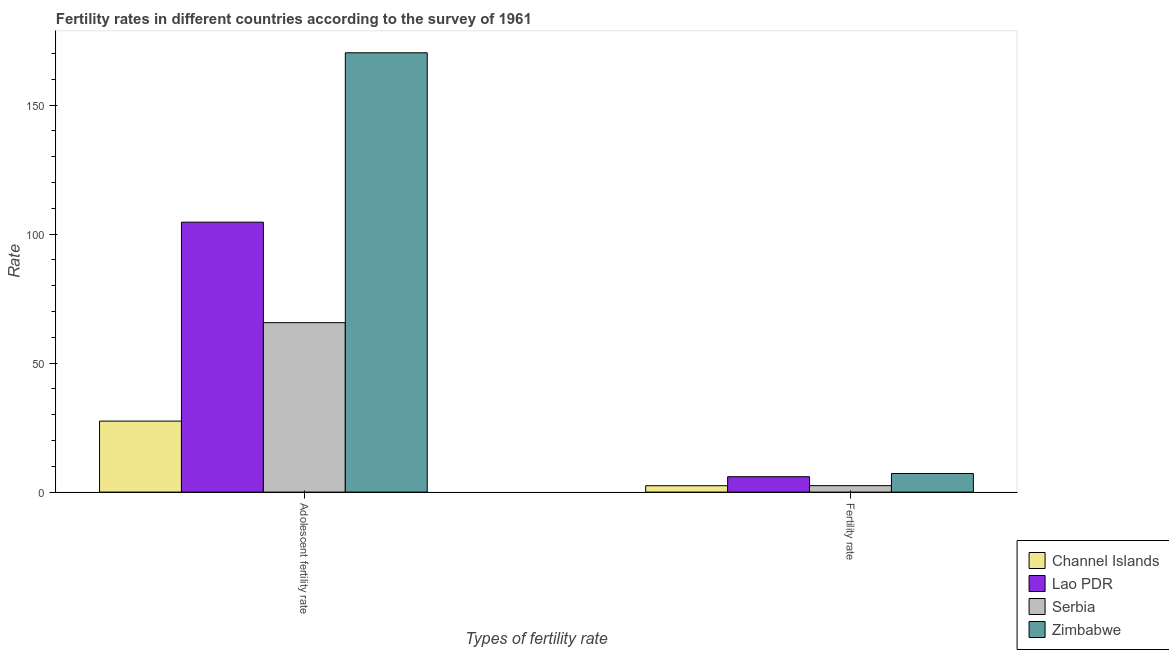How many bars are there on the 2nd tick from the right?
Ensure brevity in your answer.  4. What is the label of the 1st group of bars from the left?
Your response must be concise. Adolescent fertility rate. What is the adolescent fertility rate in Lao PDR?
Offer a terse response. 104.62. Across all countries, what is the maximum adolescent fertility rate?
Keep it short and to the point. 170.28. Across all countries, what is the minimum fertility rate?
Give a very brief answer. 2.48. In which country was the adolescent fertility rate maximum?
Offer a terse response. Zimbabwe. In which country was the adolescent fertility rate minimum?
Provide a succinct answer. Channel Islands. What is the total adolescent fertility rate in the graph?
Provide a succinct answer. 368.1. What is the difference between the fertility rate in Serbia and that in Lao PDR?
Offer a very short reply. -3.46. What is the difference between the adolescent fertility rate in Channel Islands and the fertility rate in Zimbabwe?
Provide a short and direct response. 20.3. What is the average adolescent fertility rate per country?
Offer a terse response. 92.03. What is the difference between the adolescent fertility rate and fertility rate in Lao PDR?
Keep it short and to the point. 98.66. In how many countries, is the adolescent fertility rate greater than 60 ?
Make the answer very short. 3. What is the ratio of the adolescent fertility rate in Zimbabwe to that in Serbia?
Offer a very short reply. 2.59. In how many countries, is the adolescent fertility rate greater than the average adolescent fertility rate taken over all countries?
Make the answer very short. 2. What does the 4th bar from the left in Adolescent fertility rate represents?
Provide a succinct answer. Zimbabwe. What does the 3rd bar from the right in Fertility rate represents?
Your answer should be compact. Lao PDR. How many bars are there?
Keep it short and to the point. 8. How many countries are there in the graph?
Make the answer very short. 4. What is the difference between two consecutive major ticks on the Y-axis?
Give a very brief answer. 50. Where does the legend appear in the graph?
Keep it short and to the point. Bottom right. How many legend labels are there?
Offer a very short reply. 4. What is the title of the graph?
Keep it short and to the point. Fertility rates in different countries according to the survey of 1961. Does "Central Europe" appear as one of the legend labels in the graph?
Offer a very short reply. No. What is the label or title of the X-axis?
Provide a short and direct response. Types of fertility rate. What is the label or title of the Y-axis?
Keep it short and to the point. Rate. What is the Rate in Channel Islands in Adolescent fertility rate?
Provide a short and direct response. 27.52. What is the Rate in Lao PDR in Adolescent fertility rate?
Your response must be concise. 104.62. What is the Rate in Serbia in Adolescent fertility rate?
Ensure brevity in your answer.  65.67. What is the Rate of Zimbabwe in Adolescent fertility rate?
Give a very brief answer. 170.28. What is the Rate in Channel Islands in Fertility rate?
Your answer should be very brief. 2.48. What is the Rate in Lao PDR in Fertility rate?
Your answer should be very brief. 5.96. What is the Rate in Serbia in Fertility rate?
Offer a terse response. 2.5. What is the Rate in Zimbabwe in Fertility rate?
Your response must be concise. 7.21. Across all Types of fertility rate, what is the maximum Rate of Channel Islands?
Your answer should be very brief. 27.52. Across all Types of fertility rate, what is the maximum Rate of Lao PDR?
Offer a terse response. 104.62. Across all Types of fertility rate, what is the maximum Rate in Serbia?
Provide a short and direct response. 65.67. Across all Types of fertility rate, what is the maximum Rate in Zimbabwe?
Give a very brief answer. 170.28. Across all Types of fertility rate, what is the minimum Rate of Channel Islands?
Make the answer very short. 2.48. Across all Types of fertility rate, what is the minimum Rate of Lao PDR?
Your response must be concise. 5.96. Across all Types of fertility rate, what is the minimum Rate of Serbia?
Give a very brief answer. 2.5. Across all Types of fertility rate, what is the minimum Rate in Zimbabwe?
Make the answer very short. 7.21. What is the total Rate of Channel Islands in the graph?
Ensure brevity in your answer.  30. What is the total Rate of Lao PDR in the graph?
Offer a terse response. 110.59. What is the total Rate in Serbia in the graph?
Keep it short and to the point. 68.17. What is the total Rate of Zimbabwe in the graph?
Keep it short and to the point. 177.5. What is the difference between the Rate in Channel Islands in Adolescent fertility rate and that in Fertility rate?
Keep it short and to the point. 25.04. What is the difference between the Rate of Lao PDR in Adolescent fertility rate and that in Fertility rate?
Provide a succinct answer. 98.66. What is the difference between the Rate in Serbia in Adolescent fertility rate and that in Fertility rate?
Your answer should be compact. 63.17. What is the difference between the Rate of Zimbabwe in Adolescent fertility rate and that in Fertility rate?
Your answer should be compact. 163.07. What is the difference between the Rate of Channel Islands in Adolescent fertility rate and the Rate of Lao PDR in Fertility rate?
Your answer should be compact. 21.55. What is the difference between the Rate in Channel Islands in Adolescent fertility rate and the Rate in Serbia in Fertility rate?
Provide a short and direct response. 25.02. What is the difference between the Rate in Channel Islands in Adolescent fertility rate and the Rate in Zimbabwe in Fertility rate?
Provide a short and direct response. 20.3. What is the difference between the Rate of Lao PDR in Adolescent fertility rate and the Rate of Serbia in Fertility rate?
Offer a very short reply. 102.12. What is the difference between the Rate of Lao PDR in Adolescent fertility rate and the Rate of Zimbabwe in Fertility rate?
Offer a very short reply. 97.41. What is the difference between the Rate of Serbia in Adolescent fertility rate and the Rate of Zimbabwe in Fertility rate?
Offer a very short reply. 58.46. What is the average Rate in Channel Islands per Types of fertility rate?
Offer a terse response. 15. What is the average Rate of Lao PDR per Types of fertility rate?
Your answer should be compact. 55.29. What is the average Rate in Serbia per Types of fertility rate?
Offer a terse response. 34.09. What is the average Rate of Zimbabwe per Types of fertility rate?
Ensure brevity in your answer.  88.75. What is the difference between the Rate of Channel Islands and Rate of Lao PDR in Adolescent fertility rate?
Offer a very short reply. -77.11. What is the difference between the Rate of Channel Islands and Rate of Serbia in Adolescent fertility rate?
Provide a succinct answer. -38.15. What is the difference between the Rate in Channel Islands and Rate in Zimbabwe in Adolescent fertility rate?
Make the answer very short. -142.77. What is the difference between the Rate of Lao PDR and Rate of Serbia in Adolescent fertility rate?
Ensure brevity in your answer.  38.95. What is the difference between the Rate in Lao PDR and Rate in Zimbabwe in Adolescent fertility rate?
Ensure brevity in your answer.  -65.66. What is the difference between the Rate of Serbia and Rate of Zimbabwe in Adolescent fertility rate?
Give a very brief answer. -104.61. What is the difference between the Rate in Channel Islands and Rate in Lao PDR in Fertility rate?
Offer a very short reply. -3.48. What is the difference between the Rate in Channel Islands and Rate in Serbia in Fertility rate?
Offer a terse response. -0.02. What is the difference between the Rate of Channel Islands and Rate of Zimbabwe in Fertility rate?
Provide a short and direct response. -4.73. What is the difference between the Rate of Lao PDR and Rate of Serbia in Fertility rate?
Offer a terse response. 3.46. What is the difference between the Rate in Lao PDR and Rate in Zimbabwe in Fertility rate?
Offer a terse response. -1.25. What is the difference between the Rate of Serbia and Rate of Zimbabwe in Fertility rate?
Your answer should be compact. -4.71. What is the ratio of the Rate of Channel Islands in Adolescent fertility rate to that in Fertility rate?
Make the answer very short. 11.09. What is the ratio of the Rate of Lao PDR in Adolescent fertility rate to that in Fertility rate?
Offer a terse response. 17.54. What is the ratio of the Rate in Serbia in Adolescent fertility rate to that in Fertility rate?
Offer a very short reply. 26.27. What is the ratio of the Rate of Zimbabwe in Adolescent fertility rate to that in Fertility rate?
Offer a very short reply. 23.6. What is the difference between the highest and the second highest Rate in Channel Islands?
Your answer should be compact. 25.04. What is the difference between the highest and the second highest Rate of Lao PDR?
Provide a succinct answer. 98.66. What is the difference between the highest and the second highest Rate of Serbia?
Give a very brief answer. 63.17. What is the difference between the highest and the second highest Rate in Zimbabwe?
Provide a succinct answer. 163.07. What is the difference between the highest and the lowest Rate in Channel Islands?
Your response must be concise. 25.04. What is the difference between the highest and the lowest Rate in Lao PDR?
Your answer should be compact. 98.66. What is the difference between the highest and the lowest Rate of Serbia?
Offer a very short reply. 63.17. What is the difference between the highest and the lowest Rate of Zimbabwe?
Ensure brevity in your answer.  163.07. 